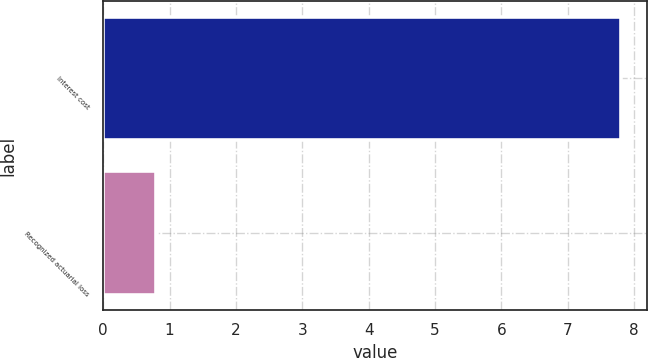Convert chart to OTSL. <chart><loc_0><loc_0><loc_500><loc_500><bar_chart><fcel>Interest cost<fcel>Recognized actuarial loss<nl><fcel>7.8<fcel>0.8<nl></chart> 